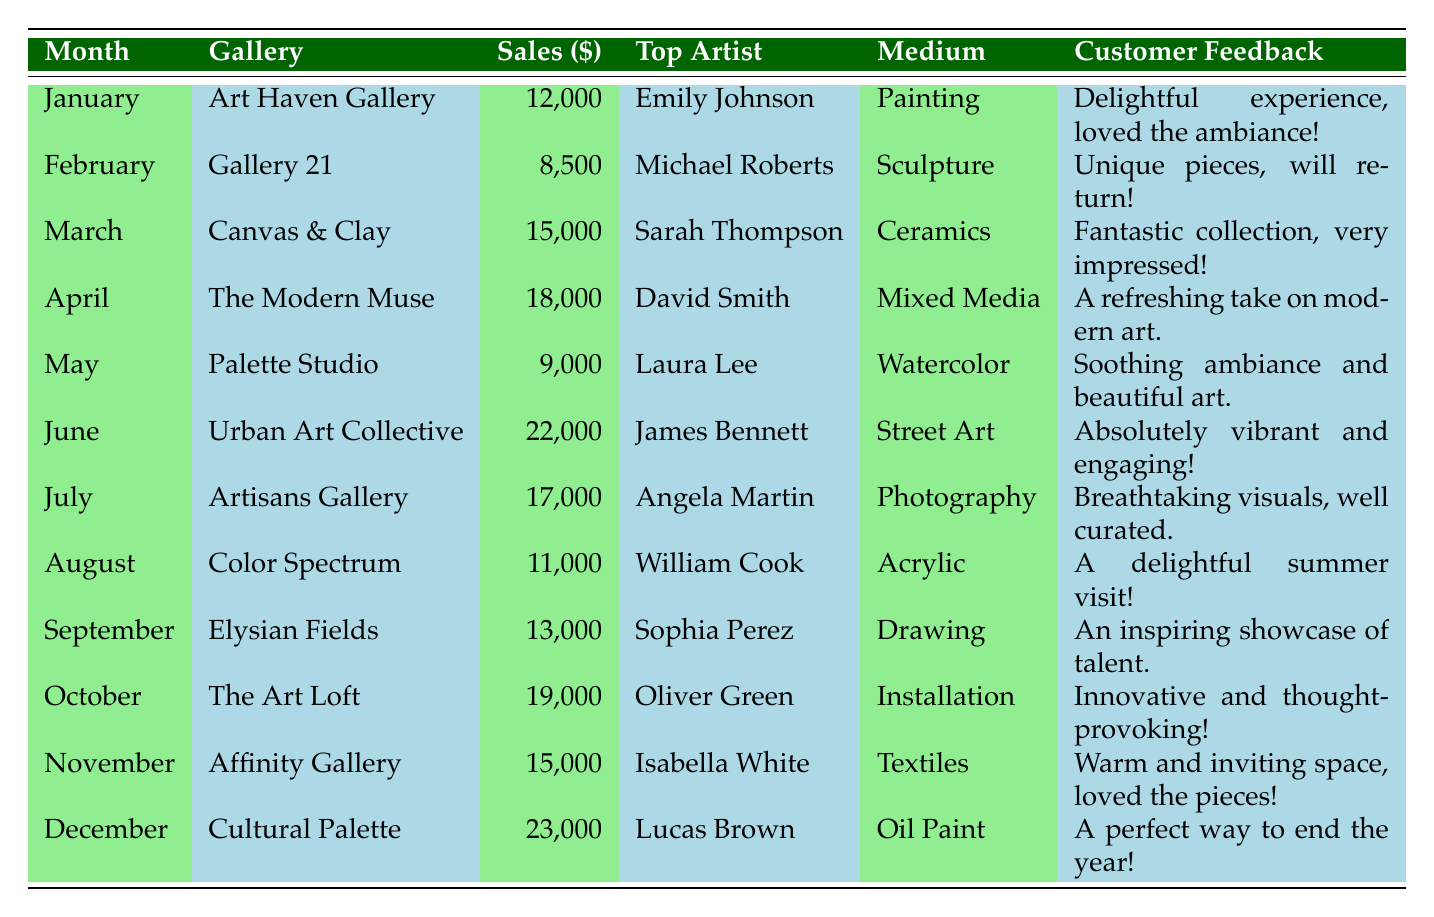What was the top-selling artist in June? Referring to the table, the record for June lists the top-selling artist as James Bennett.
Answer: James Bennett Which gallery had the highest sales volume? By scanning the sales volumes for each gallery, I find that Cultural Palette in December topped the list with $23,000.
Answer: Cultural Palette How many sales did Art Haven Gallery make in January? The table states that Art Haven Gallery had a sales volume of $12,000 in January.
Answer: $12,000 What is the average sales volume for the months of April to June? The sales volumes for April, May, and June are $18,000, $9,000, and $22,000 respectively. Summing these gives $18,000 + $9,000 + $22,000 = $49,000. The average is $49,000 divided by 3, which equals approximately $16,333.33.
Answer: $16,333.33 Did any gallery have a sales volume lower than $10,000? Looking at the sales volumes in the table, both Gallery 21 in February ($8,500) and Palette Studio in May ($9,000) had sales lower than $10,000.
Answer: Yes Which medium had the top-selling artist in November? The table shows that Isabella White had the highest sales in November, and she was associated with Textiles.
Answer: Textiles What was the difference in sales volume between the months of June and July? The sales volume in June was $22,000, while in July it was $17,000. The difference is $22,000 - $17,000 = $5,000.
Answer: $5,000 Identify the month with the second-highest sales volume and its corresponding gallery. The second-highest sales volume after December's $23,000 was June's $22,000 recorded at Urban Art Collective.
Answer: June, Urban Art Collective How many months had sales above $15,000? By reviewing the sales volumes in the table, I count six months: March, April, June, July, October, and December, all exceeding $15,000.
Answer: 6 What was the customer feedback for the gallery with the highest sales? The highest sales were recorded at Cultural Palette, which got customer feedback stating, "A perfect way to end the year!"
Answer: "A perfect way to end the year!" 